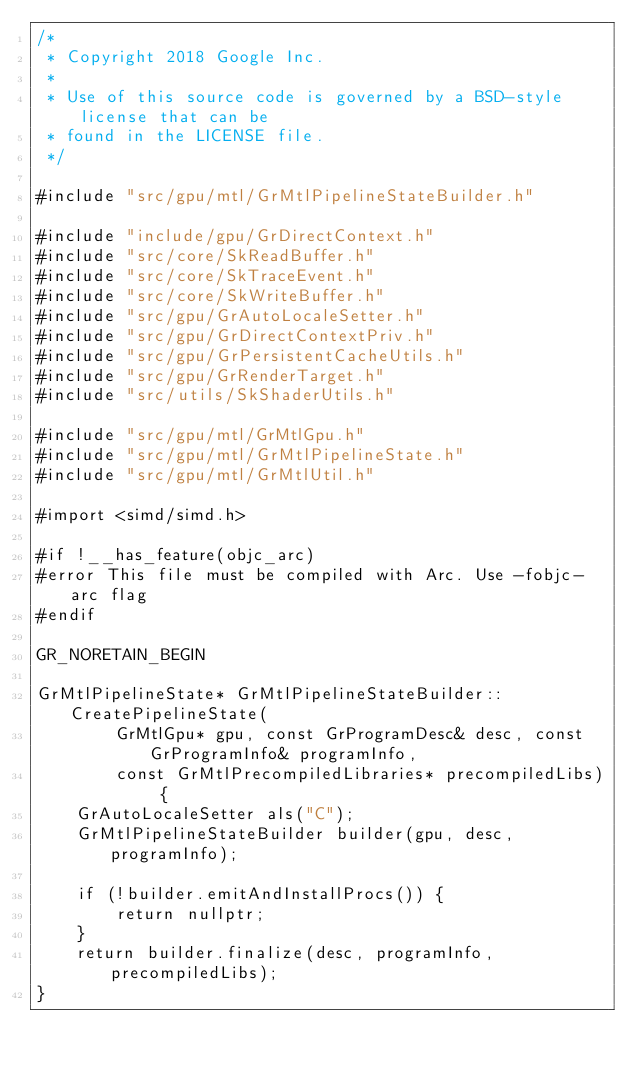<code> <loc_0><loc_0><loc_500><loc_500><_ObjectiveC_>/*
 * Copyright 2018 Google Inc.
 *
 * Use of this source code is governed by a BSD-style license that can be
 * found in the LICENSE file.
 */

#include "src/gpu/mtl/GrMtlPipelineStateBuilder.h"

#include "include/gpu/GrDirectContext.h"
#include "src/core/SkReadBuffer.h"
#include "src/core/SkTraceEvent.h"
#include "src/core/SkWriteBuffer.h"
#include "src/gpu/GrAutoLocaleSetter.h"
#include "src/gpu/GrDirectContextPriv.h"
#include "src/gpu/GrPersistentCacheUtils.h"
#include "src/gpu/GrRenderTarget.h"
#include "src/utils/SkShaderUtils.h"

#include "src/gpu/mtl/GrMtlGpu.h"
#include "src/gpu/mtl/GrMtlPipelineState.h"
#include "src/gpu/mtl/GrMtlUtil.h"

#import <simd/simd.h>

#if !__has_feature(objc_arc)
#error This file must be compiled with Arc. Use -fobjc-arc flag
#endif

GR_NORETAIN_BEGIN

GrMtlPipelineState* GrMtlPipelineStateBuilder::CreatePipelineState(
        GrMtlGpu* gpu, const GrProgramDesc& desc, const GrProgramInfo& programInfo,
        const GrMtlPrecompiledLibraries* precompiledLibs) {
    GrAutoLocaleSetter als("C");
    GrMtlPipelineStateBuilder builder(gpu, desc, programInfo);

    if (!builder.emitAndInstallProcs()) {
        return nullptr;
    }
    return builder.finalize(desc, programInfo, precompiledLibs);
}
</code> 